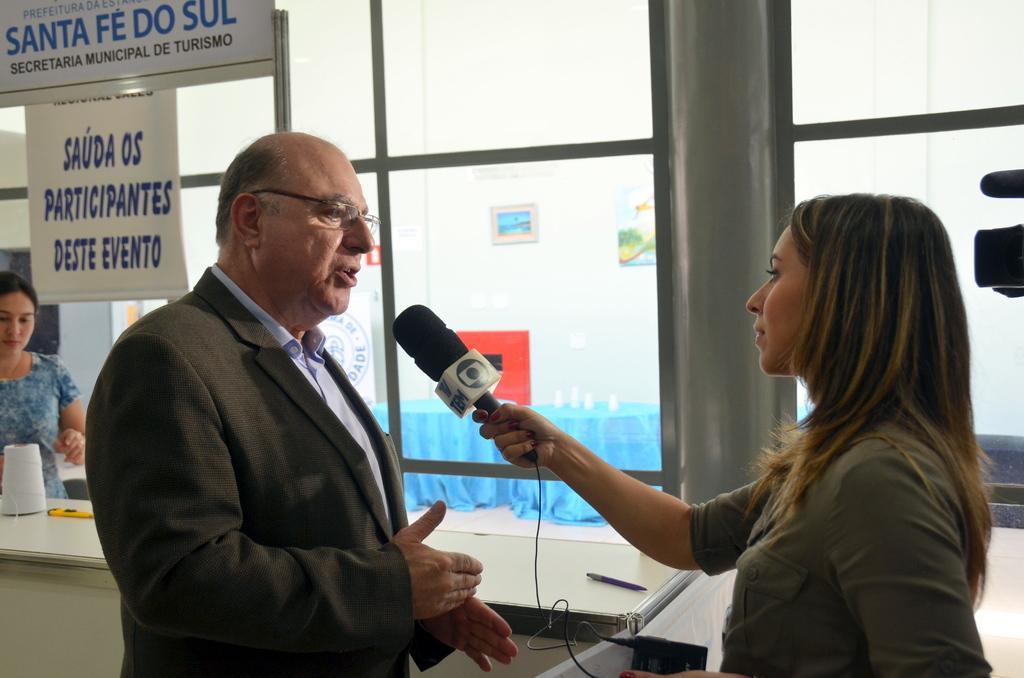In one or two sentences, can you explain what this image depicts? This man and this woman are highlighted in this picture. This woman is holding a mic. This man is speaking in-front of a mic, as there is a hand movement. Far a woman is standing beside this table. On this table there is a roll and pen. To this glass window there are posters. 